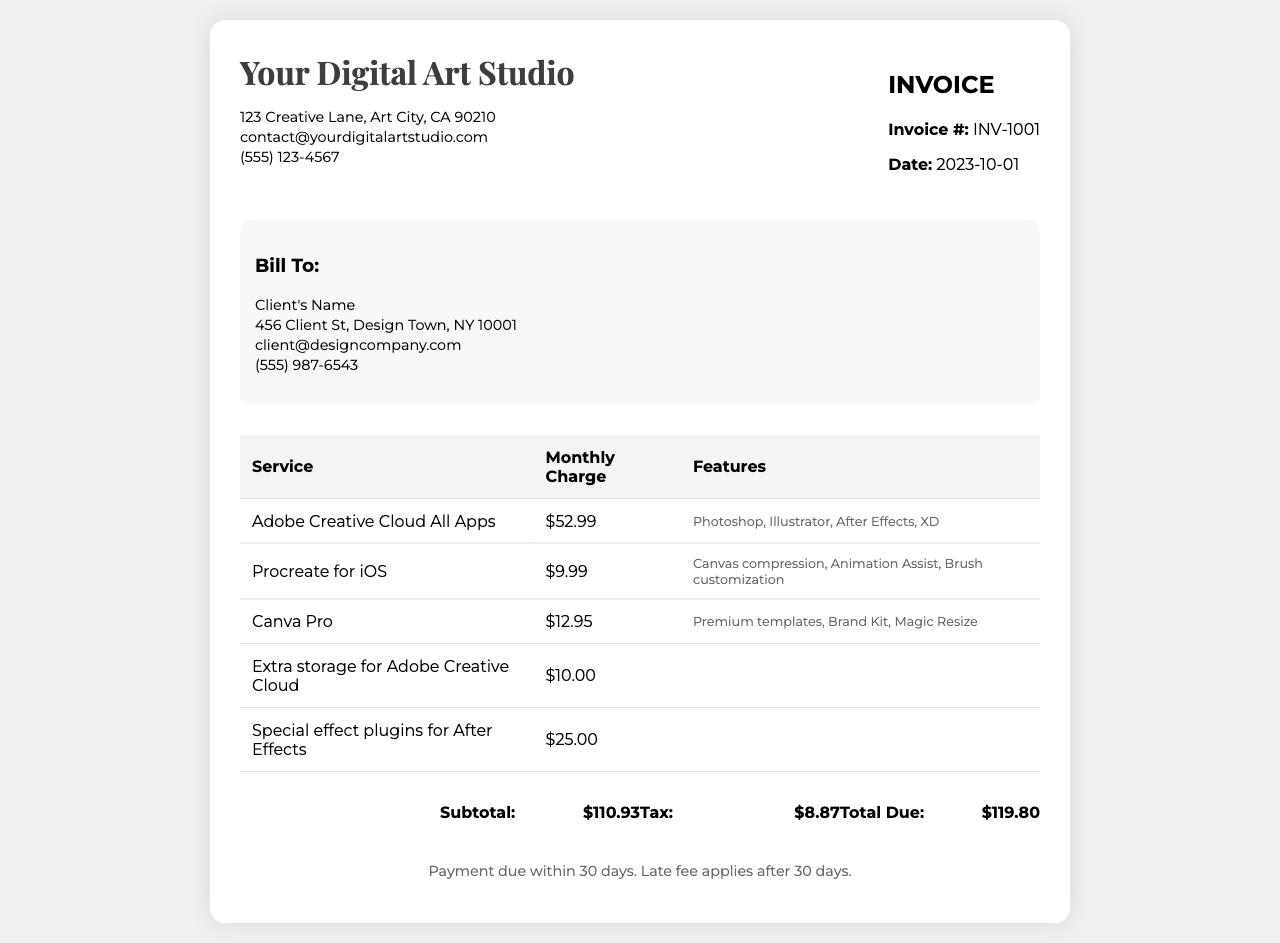What is the invoice number? The invoice number is listed in the document under the invoice details section.
Answer: INV-1001 What is the total due amount? The total due amount is the final sum at the bottom of the invoice, which includes the subtotal and tax.
Answer: $119.80 Who is the client? The client's name is provided in the bill-to section of the invoice.
Answer: Client's Name What is the monthly charge for Adobe Creative Cloud All Apps? The monthly charge for Adobe Creative Cloud All Apps is specified in the service breakdown table.
Answer: $52.99 What premium feature is mentioned for Canva Pro? The additional feature for Canva Pro is indicated in the features column of the service breakdown.
Answer: Premium templates How much is the tax amount? The tax amount is calculated based on the subtotal and mentioned near the bottom of the invoice.
Answer: $8.87 What additional service has a monthly charge of $10.00? This charge is specified in the service breakdown table under extra services.
Answer: Extra storage for Adobe Creative Cloud What is the payment due date? The payment terms state the conditions under which payment is due, helping to deduce the payment timeframe.
Answer: Within 30 days What date was the invoice issued? The issue date of the invoice is mentioned under the invoice details section.
Answer: 2023-10-01 